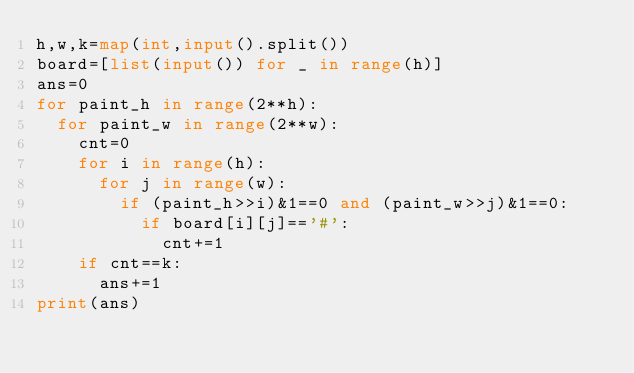<code> <loc_0><loc_0><loc_500><loc_500><_Python_>h,w,k=map(int,input().split())
board=[list(input()) for _ in range(h)]
ans=0
for paint_h in range(2**h):
  for paint_w in range(2**w):
    cnt=0
    for i in range(h):
      for j in range(w):
        if (paint_h>>i)&1==0 and (paint_w>>j)&1==0:
          if board[i][j]=='#':
            cnt+=1
    if cnt==k:
      ans+=1
print(ans)</code> 